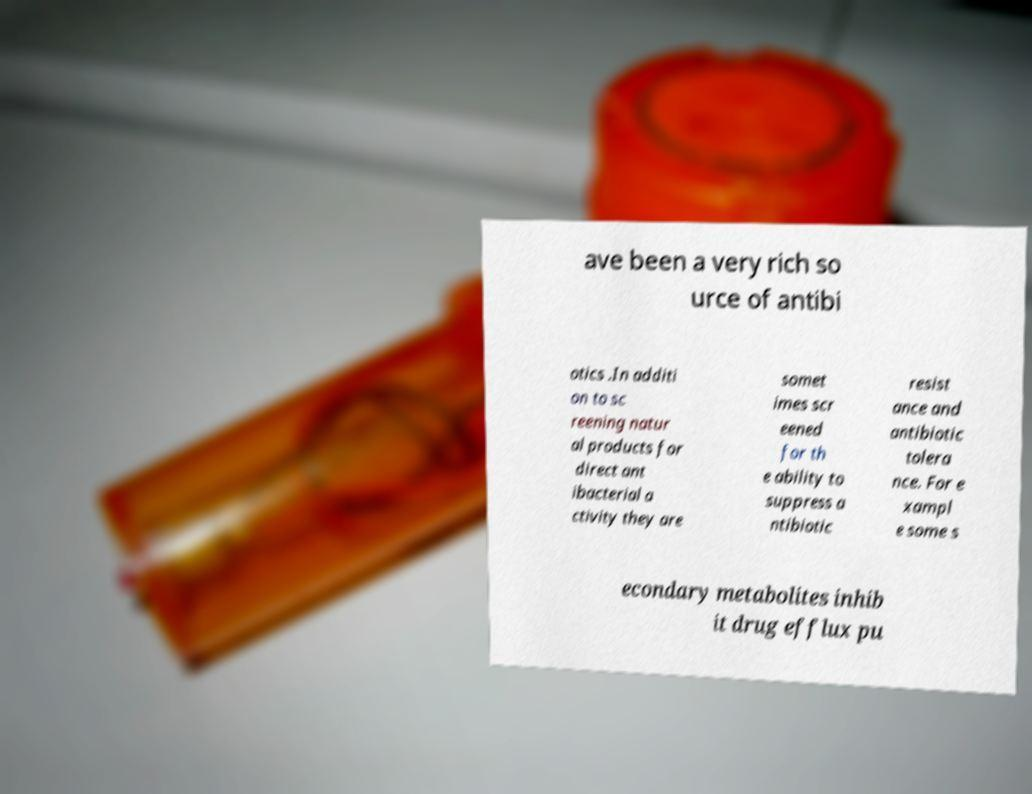Can you read and provide the text displayed in the image?This photo seems to have some interesting text. Can you extract and type it out for me? ave been a very rich so urce of antibi otics .In additi on to sc reening natur al products for direct ant ibacterial a ctivity they are somet imes scr eened for th e ability to suppress a ntibiotic resist ance and antibiotic tolera nce. For e xampl e some s econdary metabolites inhib it drug efflux pu 